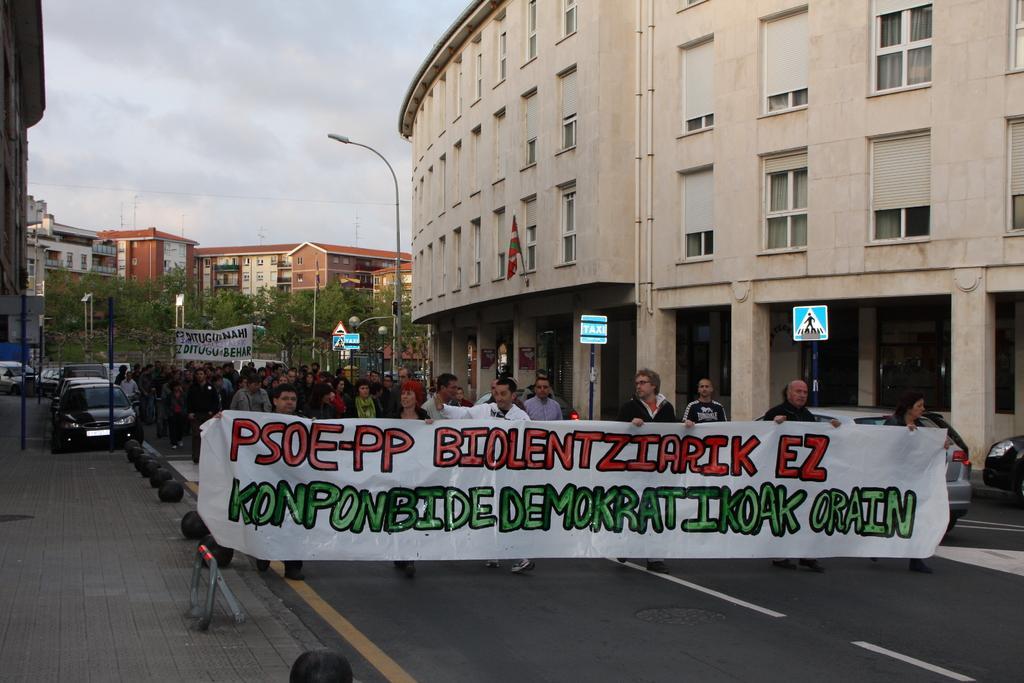In one or two sentences, can you explain what this image depicts? In this image there are group of people walking along with banner, beside them there are buildings and trees. 